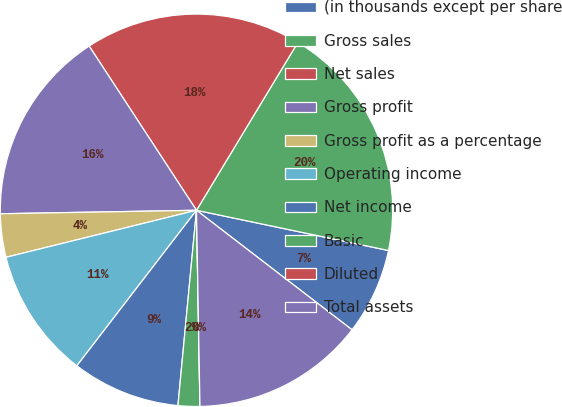Convert chart. <chart><loc_0><loc_0><loc_500><loc_500><pie_chart><fcel>(in thousands except per share<fcel>Gross sales<fcel>Net sales<fcel>Gross profit<fcel>Gross profit as a percentage<fcel>Operating income<fcel>Net income<fcel>Basic<fcel>Diluted<fcel>Total assets<nl><fcel>7.14%<fcel>19.64%<fcel>17.86%<fcel>16.07%<fcel>3.57%<fcel>10.71%<fcel>8.93%<fcel>1.79%<fcel>0.0%<fcel>14.29%<nl></chart> 